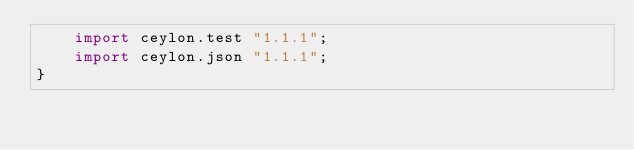Convert code to text. <code><loc_0><loc_0><loc_500><loc_500><_Ceylon_>    import ceylon.test "1.1.1";
    import ceylon.json "1.1.1";
}
</code> 